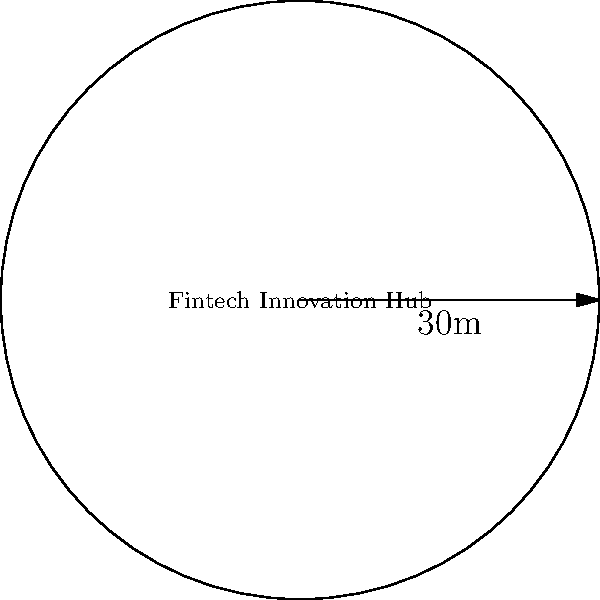A circular outdoor workspace is being planned for a fintech innovation hub. The radius of the workspace is 30 meters. What is the perimeter of this workspace, rounded to the nearest meter? To find the perimeter of a circular area, we need to use the formula for the circumference of a circle:

$$C = 2\pi r$$

Where:
$C$ = circumference (perimeter)
$\pi$ = pi (approximately 3.14159)
$r$ = radius

Given:
Radius ($r$) = 30 meters

Step 1: Substitute the given radius into the formula.
$$C = 2\pi (30)$$

Step 2: Multiply.
$$C = 60\pi$$

Step 3: Calculate the result (using 3.14159 for $\pi$).
$$C = 60 \times 3.14159 = 188.4954$$

Step 4: Round to the nearest meter.
$$C \approx 188 \text{ meters}$$

Therefore, the perimeter of the circular outdoor workspace is approximately 188 meters.
Answer: 188 meters 